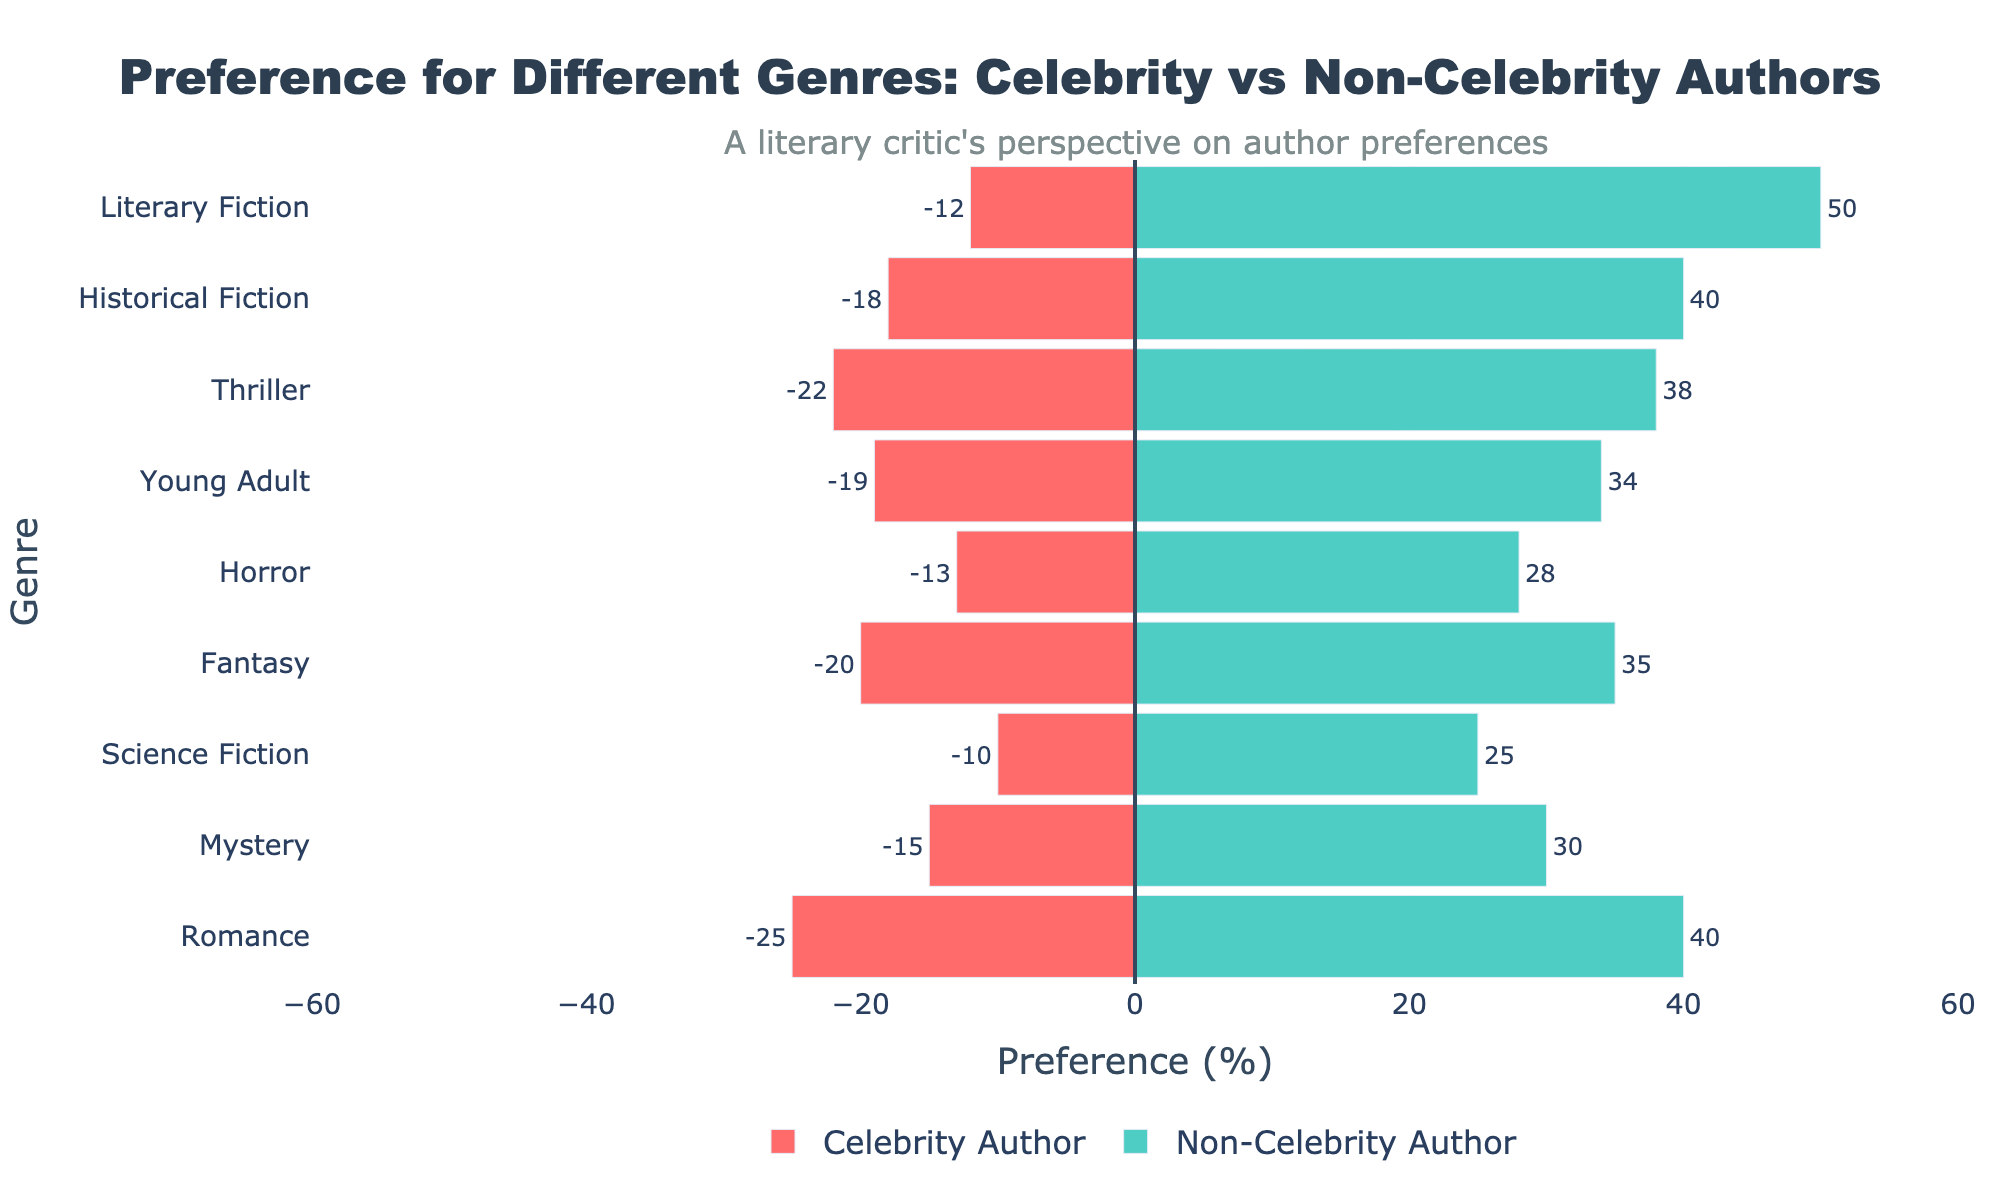What is the genre with the largest preference difference between non-celebrity and celebrity authors? By looking at the length of the bars, Literary Fiction has the biggest difference. Non-celebrity authors have a 50% preference, while celebrity authors have 12%, making a difference of 38%.
Answer: Literary Fiction Which genre do more readers prefer when authored by celebrities compared to non-celebrities? By comparing the left and right bars, no genre shows a higher preference for celebrity authors compared to non-celebrity authors.
Answer: None What is the total preference percentage for Science Fiction novels written by both celebrity and non-celebrity authors? The preference for Science Fiction is 10% for celebrity authors and 25% for non-celebrity authors. Adding them gives 10% + 25% = 35%.
Answer: 35% How many genres have a non-celebrity preference of at least 35%? By inspecting the right-side bars, Fantasy, Historical Fiction, Thriller, Young Adult, and Literary Fiction all have more than 35% preference for non-celebrity authors. There are 5 such genres.
Answer: 5 What is the average preference for celebrity authors across all genres? Sum the celebrity authors' preferences (25 + 15 + 10 + 20 + 18 + 22 + 13 + 19 + 12 = 154) and divide by the number of genres (9). 154 / 9 ≈ 17.11%.
Answer: 17.1% What is the difference in preference between celebrity and non-celebrity authors for Mystery novels? The preference for Mystery novels is 15% for celebrity authors and 30% for non-celebrity authors. The difference is 30% - 15% = 15%.
Answer: 15% Which genres have a preference percentage for non-celebrity authors between 20% and 40%? By looking at the lengths of the green bars, Mystery (30%), Science Fiction (25%), and Horror (28%) fall within this range.
Answer: Mystery, Science Fiction, Horror What is the combined preference percentage for Historical Fiction and Thriller by non-celebrity authors? Adding the preferences for Historical Fiction (40%) and Thriller (38%) gives 40% + 38% = 78%.
Answer: 78% Which genre has the smallest preference gap between celebrity and non-celebrity authors? By comparing the differences, Science Fiction has the smallest gap, with 10% for celebrity authors and 25% for non-celebrity authors, resulting in a gap of 15%.
Answer: Science Fiction 